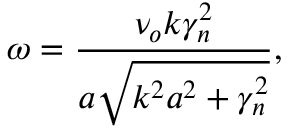<formula> <loc_0><loc_0><loc_500><loc_500>\omega = \frac { \nu _ { o } k \gamma _ { n } ^ { 2 } } { a \sqrt { k ^ { 2 } a ^ { 2 } + \gamma _ { n } ^ { 2 } } } ,</formula> 